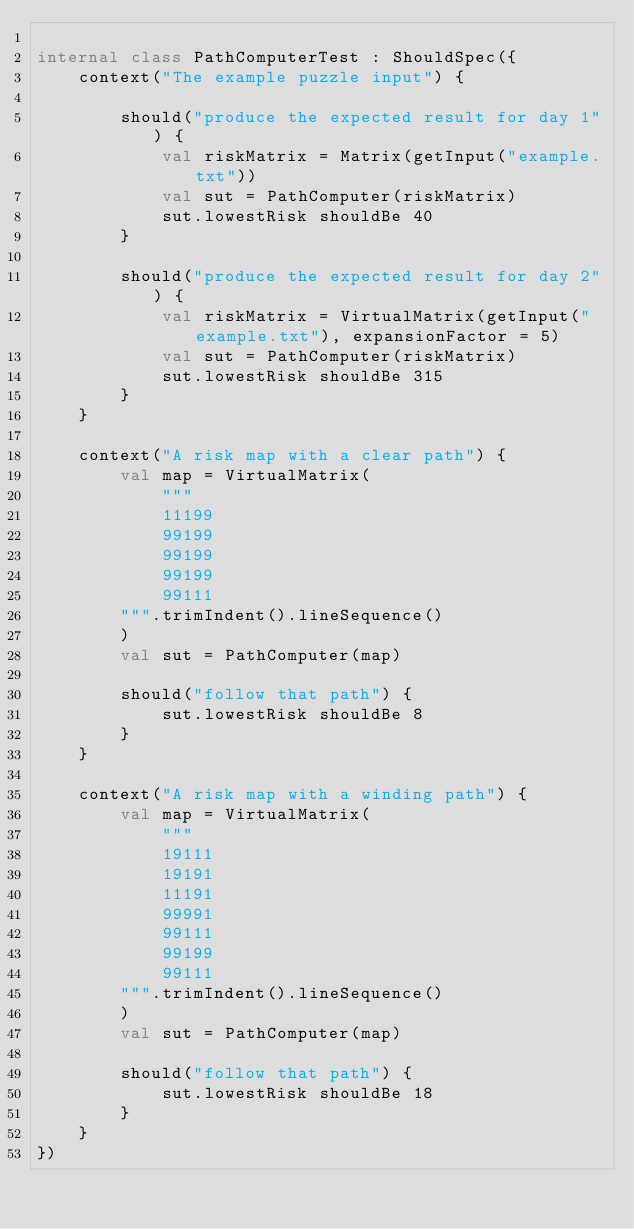<code> <loc_0><loc_0><loc_500><loc_500><_Kotlin_>
internal class PathComputerTest : ShouldSpec({
    context("The example puzzle input") {

        should("produce the expected result for day 1") {
            val riskMatrix = Matrix(getInput("example.txt"))
            val sut = PathComputer(riskMatrix)
            sut.lowestRisk shouldBe 40
        }

        should("produce the expected result for day 2") {
            val riskMatrix = VirtualMatrix(getInput("example.txt"), expansionFactor = 5)
            val sut = PathComputer(riskMatrix)
            sut.lowestRisk shouldBe 315
        }
    }

    context("A risk map with a clear path") {
        val map = VirtualMatrix(
            """
            11199
            99199
            99199
            99199
            99111
        """.trimIndent().lineSequence()
        )
        val sut = PathComputer(map)

        should("follow that path") {
            sut.lowestRisk shouldBe 8
        }
    }

    context("A risk map with a winding path") {
        val map = VirtualMatrix(
            """
            19111
            19191
            11191
            99991
            99111
            99199
            99111
        """.trimIndent().lineSequence()
        )
        val sut = PathComputer(map)

        should("follow that path") {
            sut.lowestRisk shouldBe 18
        }
    }
})
</code> 